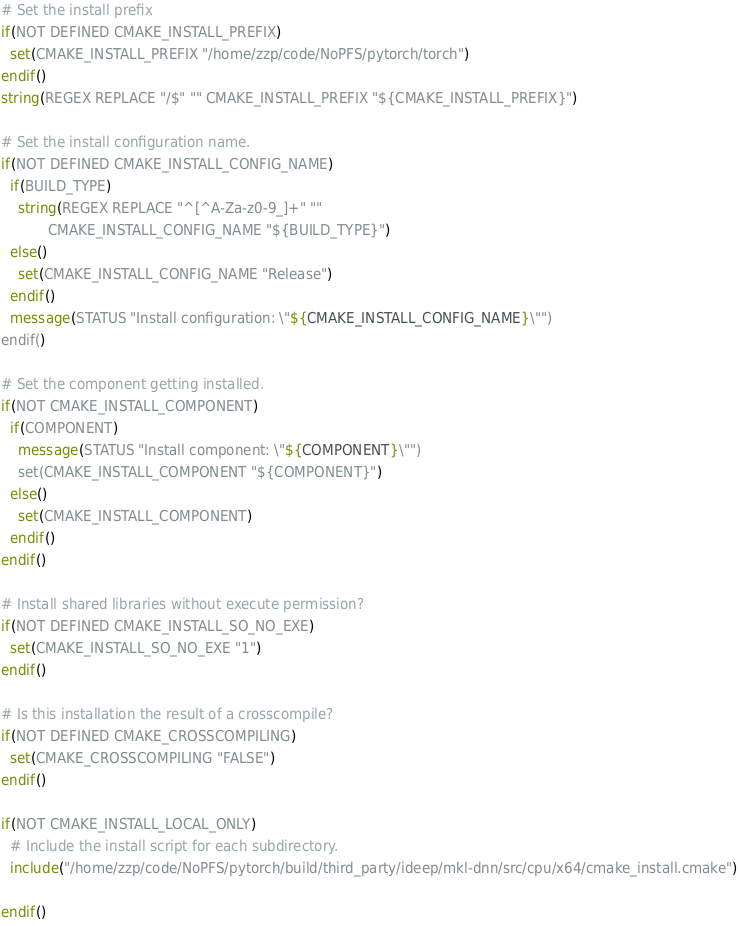<code> <loc_0><loc_0><loc_500><loc_500><_CMake_>
# Set the install prefix
if(NOT DEFINED CMAKE_INSTALL_PREFIX)
  set(CMAKE_INSTALL_PREFIX "/home/zzp/code/NoPFS/pytorch/torch")
endif()
string(REGEX REPLACE "/$" "" CMAKE_INSTALL_PREFIX "${CMAKE_INSTALL_PREFIX}")

# Set the install configuration name.
if(NOT DEFINED CMAKE_INSTALL_CONFIG_NAME)
  if(BUILD_TYPE)
    string(REGEX REPLACE "^[^A-Za-z0-9_]+" ""
           CMAKE_INSTALL_CONFIG_NAME "${BUILD_TYPE}")
  else()
    set(CMAKE_INSTALL_CONFIG_NAME "Release")
  endif()
  message(STATUS "Install configuration: \"${CMAKE_INSTALL_CONFIG_NAME}\"")
endif()

# Set the component getting installed.
if(NOT CMAKE_INSTALL_COMPONENT)
  if(COMPONENT)
    message(STATUS "Install component: \"${COMPONENT}\"")
    set(CMAKE_INSTALL_COMPONENT "${COMPONENT}")
  else()
    set(CMAKE_INSTALL_COMPONENT)
  endif()
endif()

# Install shared libraries without execute permission?
if(NOT DEFINED CMAKE_INSTALL_SO_NO_EXE)
  set(CMAKE_INSTALL_SO_NO_EXE "1")
endif()

# Is this installation the result of a crosscompile?
if(NOT DEFINED CMAKE_CROSSCOMPILING)
  set(CMAKE_CROSSCOMPILING "FALSE")
endif()

if(NOT CMAKE_INSTALL_LOCAL_ONLY)
  # Include the install script for each subdirectory.
  include("/home/zzp/code/NoPFS/pytorch/build/third_party/ideep/mkl-dnn/src/cpu/x64/cmake_install.cmake")

endif()

</code> 